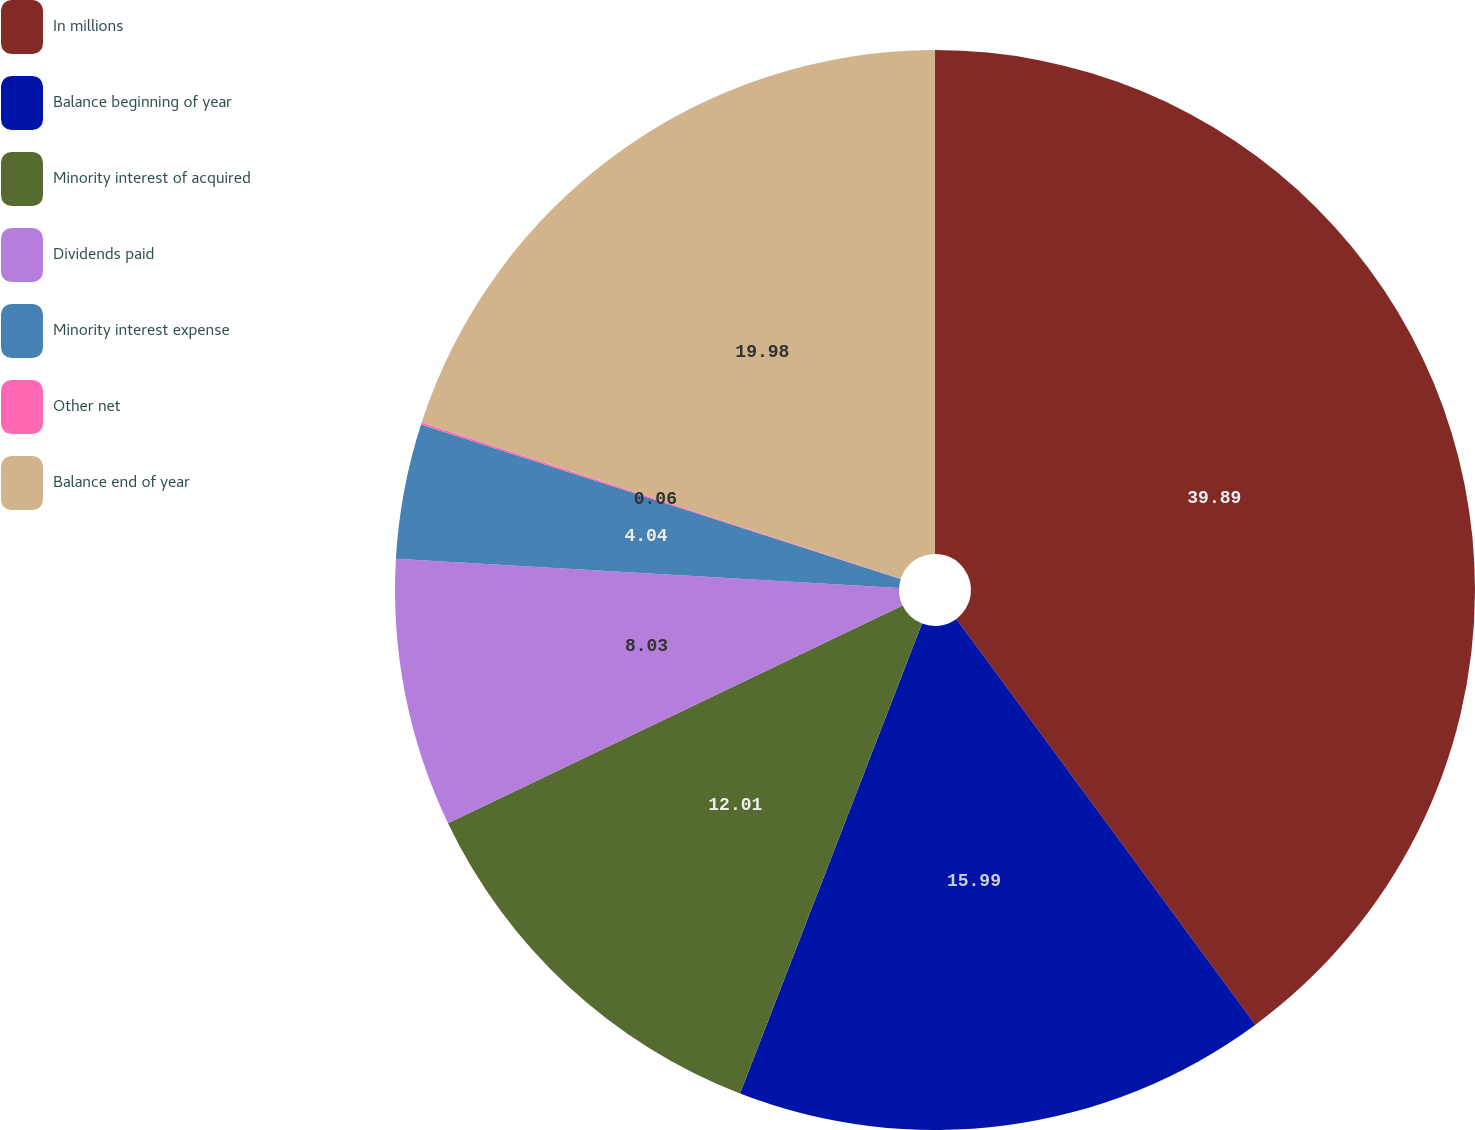Convert chart. <chart><loc_0><loc_0><loc_500><loc_500><pie_chart><fcel>In millions<fcel>Balance beginning of year<fcel>Minority interest of acquired<fcel>Dividends paid<fcel>Minority interest expense<fcel>Other net<fcel>Balance end of year<nl><fcel>39.89%<fcel>15.99%<fcel>12.01%<fcel>8.03%<fcel>4.04%<fcel>0.06%<fcel>19.98%<nl></chart> 